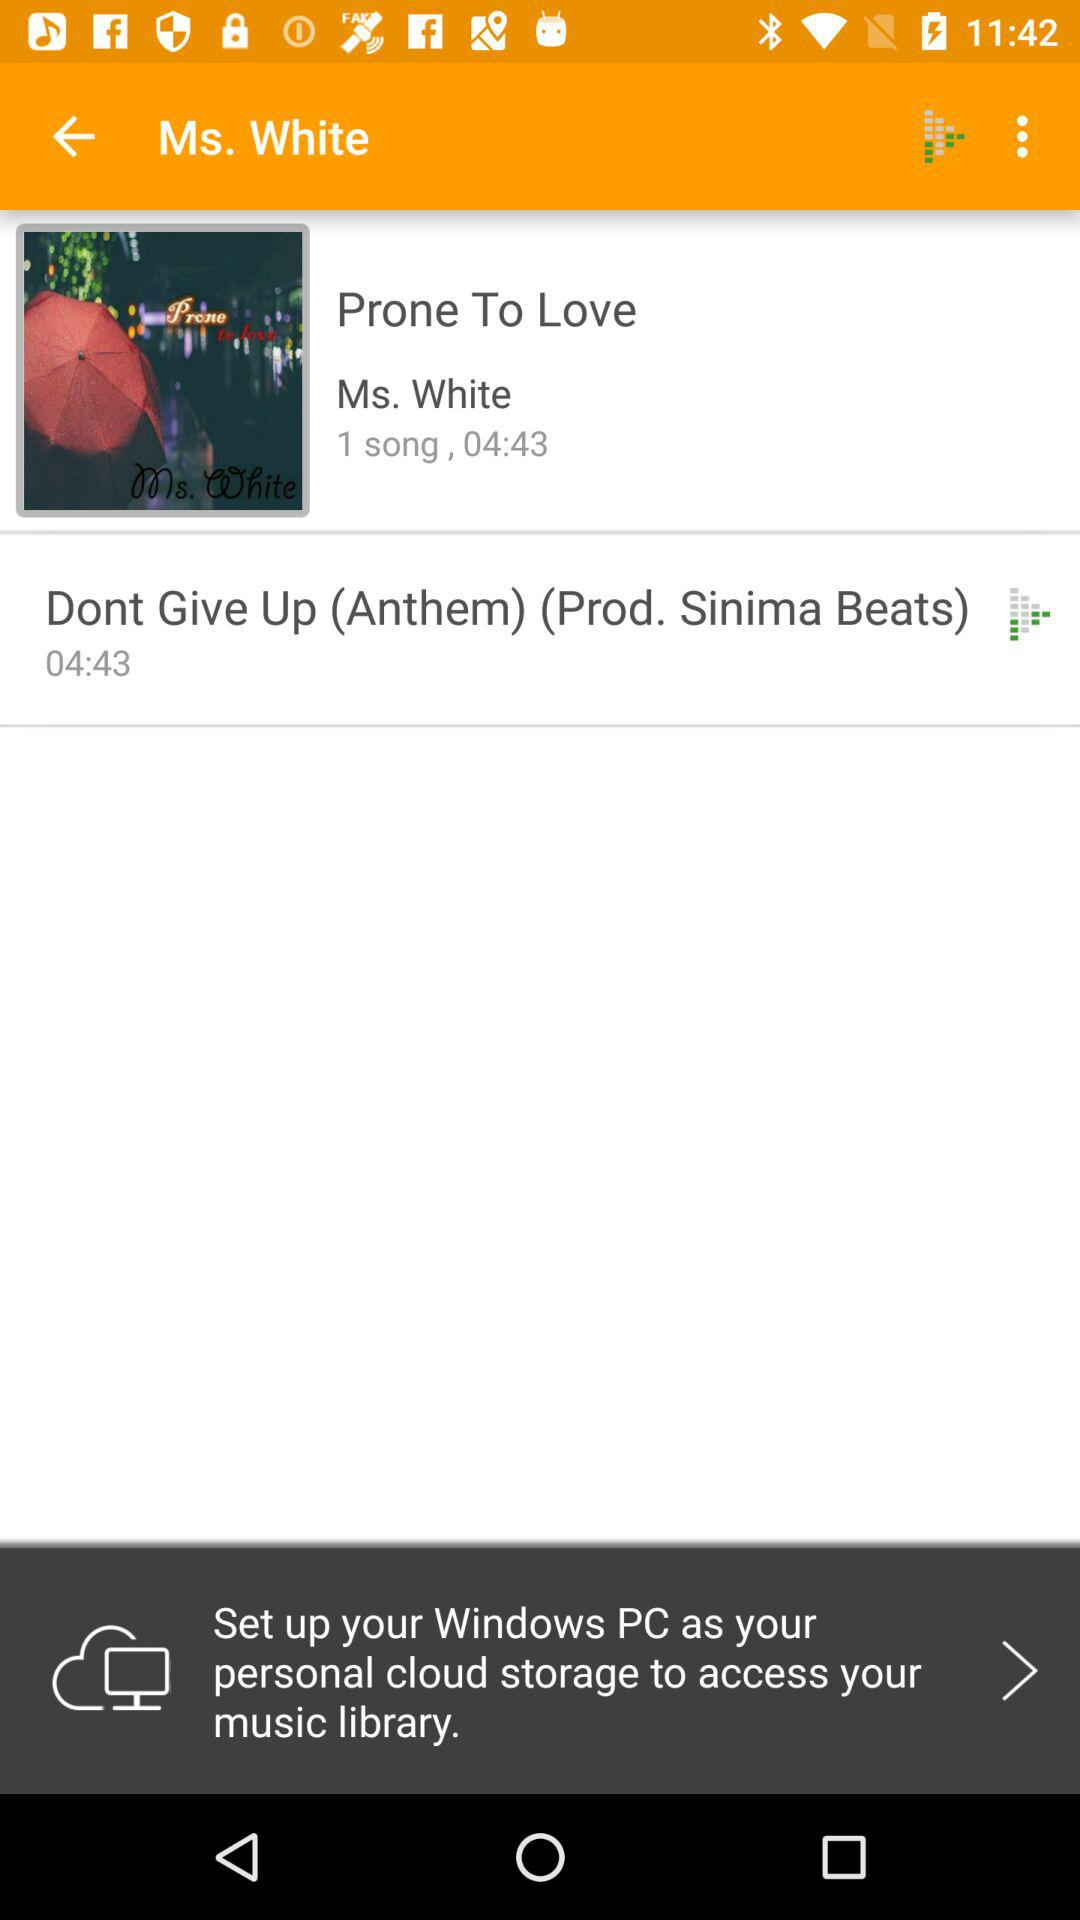What is the time duration of the song? The time duration is 4 minutes 43 seconds. 